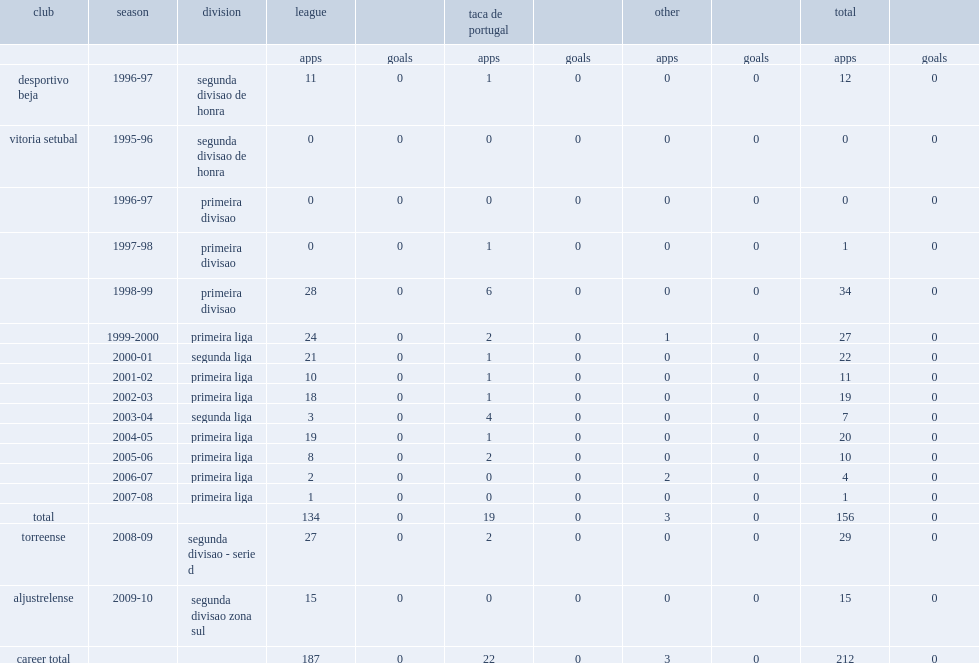What was the total number of appearances made by marco tabuas for vitoria setubal totally. 156.0. 